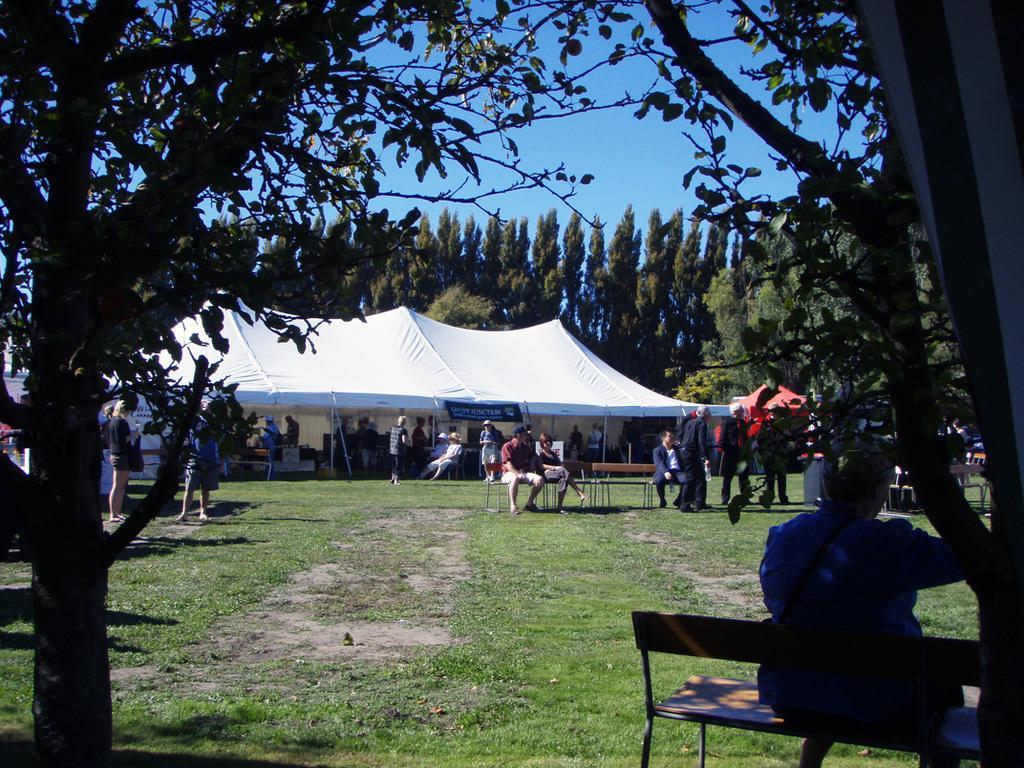Please provide a concise description of this image. In the picture we can a tent, trees, sky and some people walking, sitting and standing. 